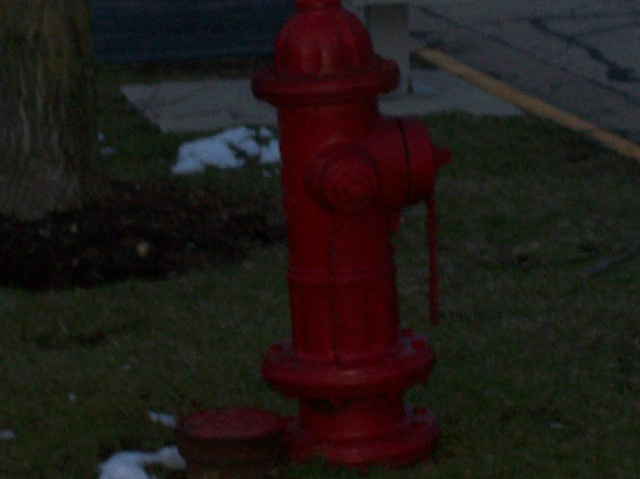Describe the objects in this image and their specific colors. I can see a fire hydrant in black and maroon tones in this image. 